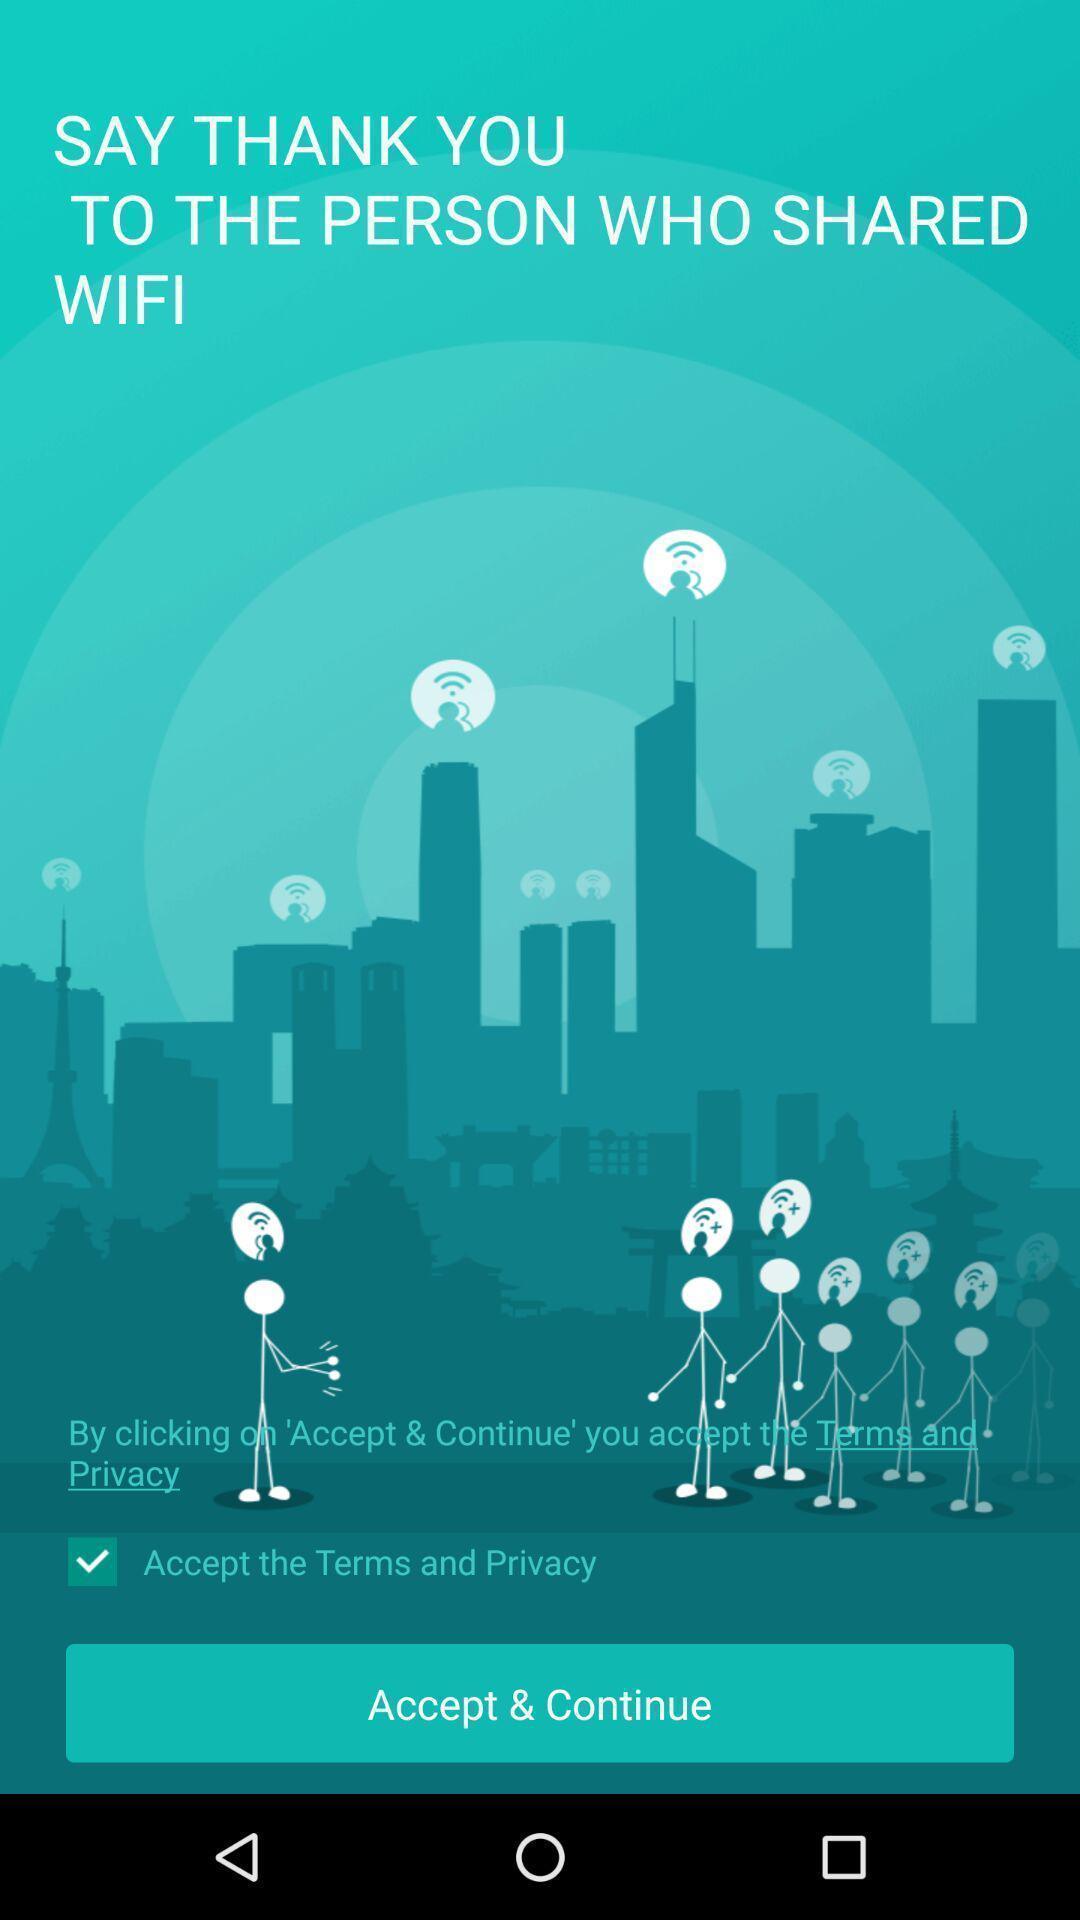Provide a textual representation of this image. Welcome page displaying to accept and continue. 